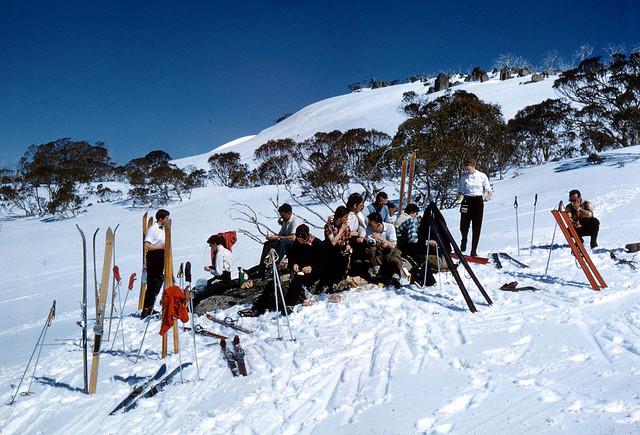Is this a special event?
Keep it brief. No. What is on the ground?
Quick response, please. Snow. Are these people experienced skiers or beginners?
Give a very brief answer. Experienced. What is the weather like here?
Concise answer only. Cold. 